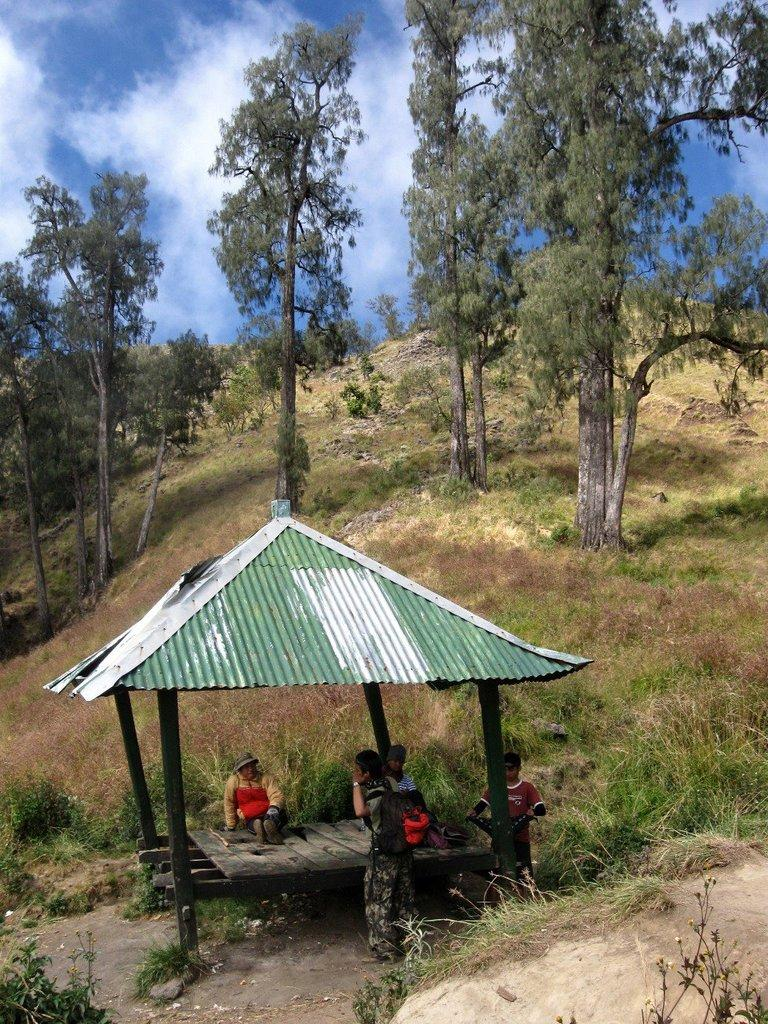What type of structure is depicted in the image? The image appears to depict a pergola. Who or what can be seen inside the pergola? There is a group of people in the pergola. What is visible behind the pergola? There are trees and grass visible behind the pergola. What can be seen in the background of the image? The sky is visible in the background of the image. What song is being sung by the people in the pergola? There is no indication in the image that the people are singing a song, so it cannot be determined from the picture. 